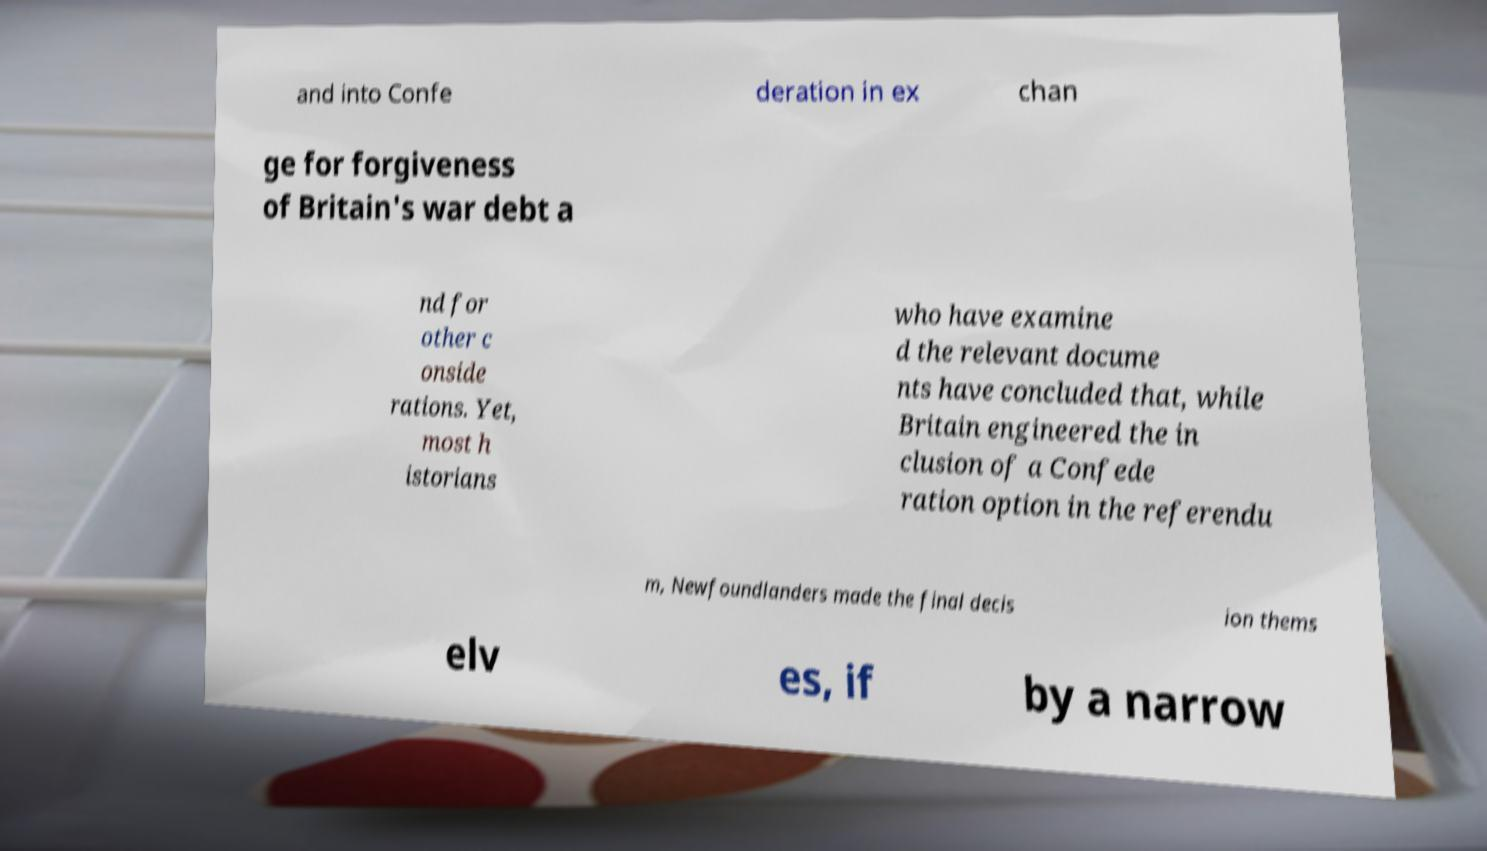For documentation purposes, I need the text within this image transcribed. Could you provide that? and into Confe deration in ex chan ge for forgiveness of Britain's war debt a nd for other c onside rations. Yet, most h istorians who have examine d the relevant docume nts have concluded that, while Britain engineered the in clusion of a Confede ration option in the referendu m, Newfoundlanders made the final decis ion thems elv es, if by a narrow 